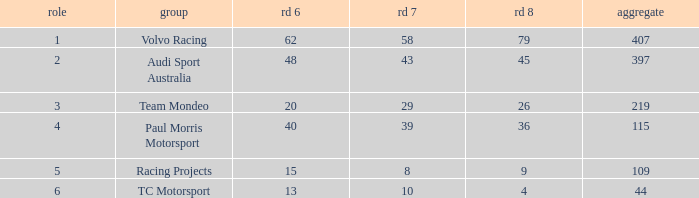What is the sum of total values for Rd 7 less than 8? None. 